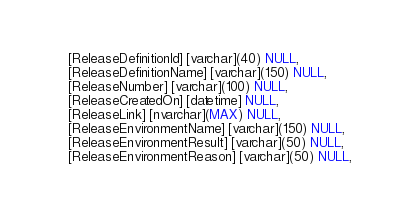<code> <loc_0><loc_0><loc_500><loc_500><_SQL_>	[ReleaseDefinitionId] [varchar](40) NULL,
	[ReleaseDefinitionName] [varchar](150) NULL,
	[ReleaseNumber] [varchar](100) NULL,
	[ReleaseCreatedOn] [datetime] NULL,
	[ReleaseLink] [nvarchar](MAX) NULL,
	[ReleaseEnvironmentName] [varchar](150) NULL,
	[ReleaseEnvironmentResult] [varchar](50) NULL,
	[ReleaseEnvironmentReason] [varchar](50) NULL,</code> 